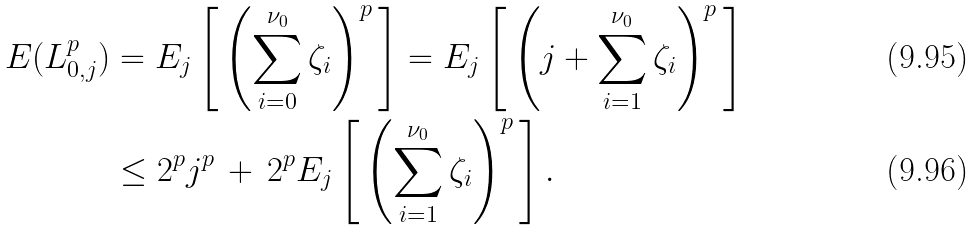<formula> <loc_0><loc_0><loc_500><loc_500>E ( L _ { 0 , j } ^ { p } ) & = E _ { j } \left [ \, \left ( \sum _ { i = 0 } ^ { \nu _ { 0 } } \zeta _ { i } \right ) ^ { p } \, \right ] = E _ { j } \left [ \, \left ( j + \sum _ { i = 1 } ^ { \nu _ { 0 } } \zeta _ { i } \right ) ^ { p } \, \right ] \\ & \leq 2 ^ { p } j ^ { p } \, + \, 2 ^ { p } E _ { j } \left [ \, \left ( \sum _ { i = 1 } ^ { \nu _ { 0 } } \zeta _ { i } \right ) ^ { p } \, \right ] .</formula> 